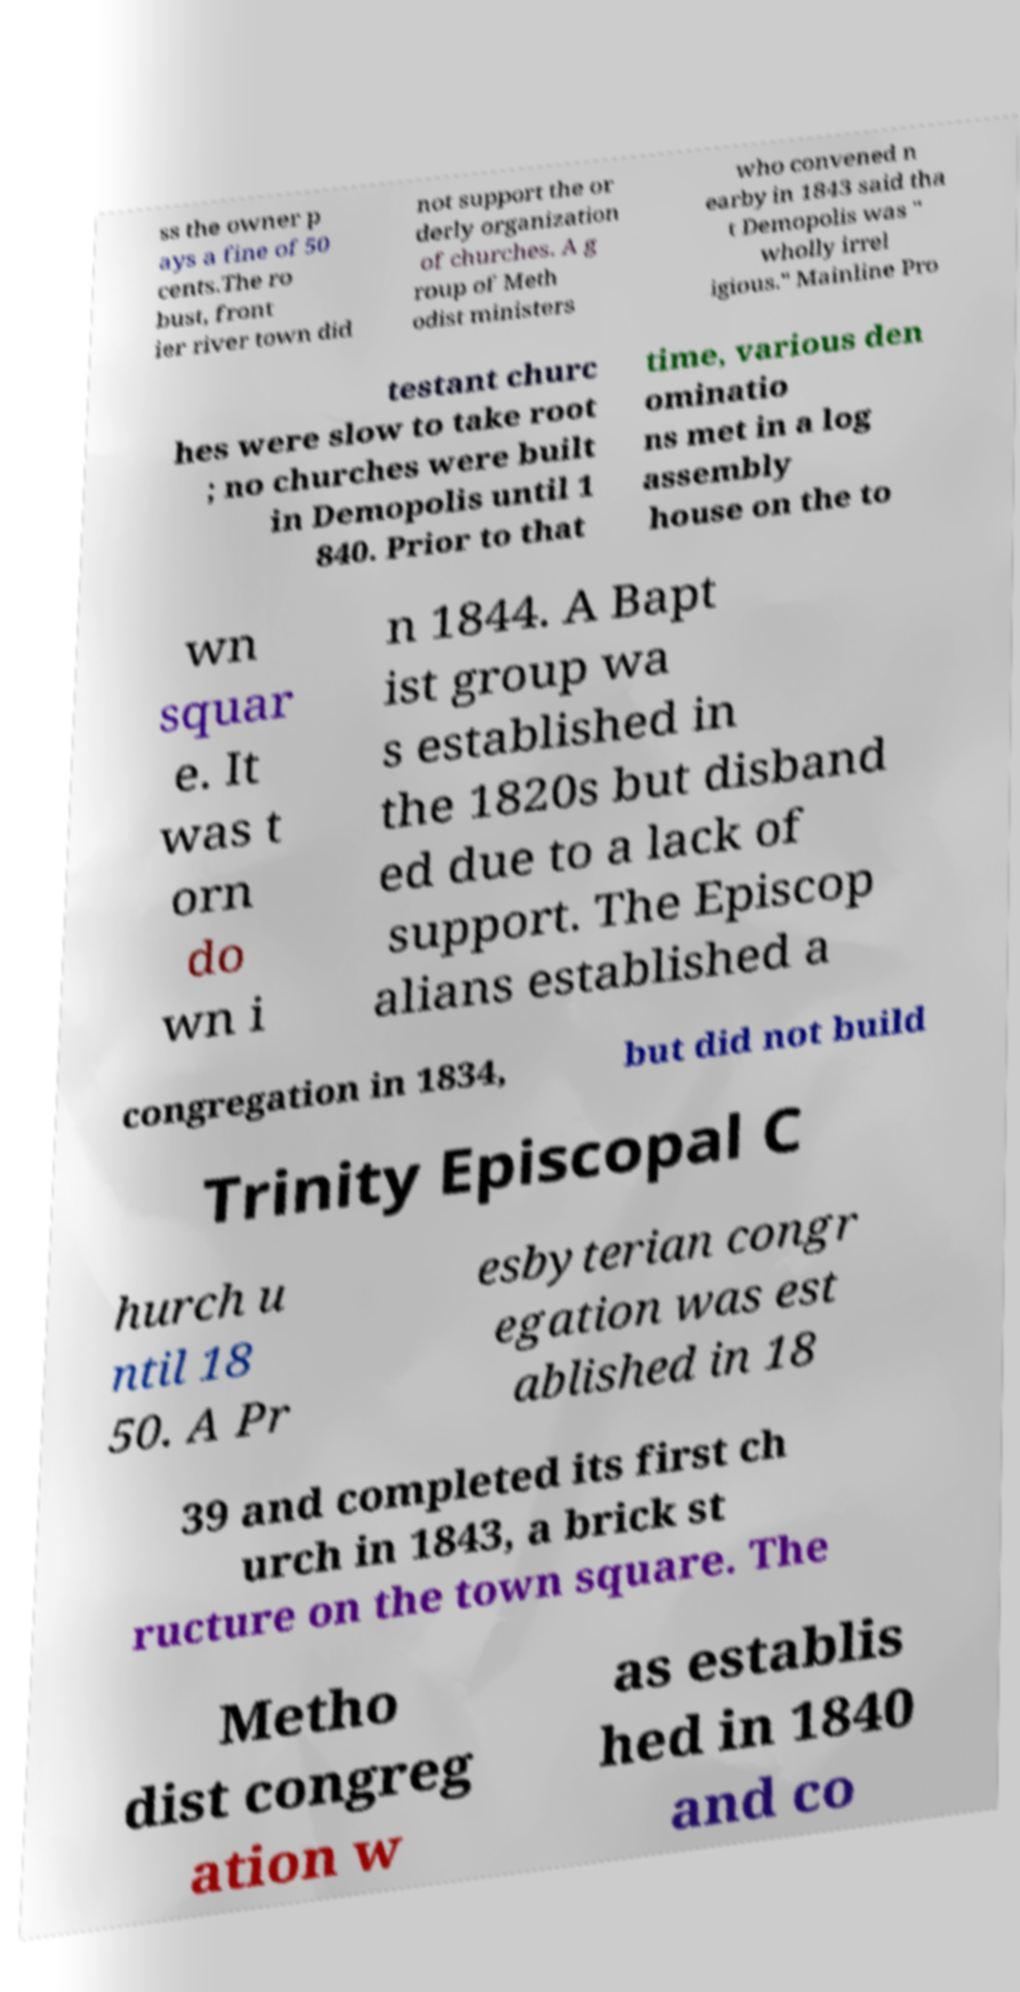Could you assist in decoding the text presented in this image and type it out clearly? ss the owner p ays a fine of 50 cents.The ro bust, front ier river town did not support the or derly organization of churches. A g roup of Meth odist ministers who convened n earby in 1843 said tha t Demopolis was " wholly irrel igious." Mainline Pro testant churc hes were slow to take root ; no churches were built in Demopolis until 1 840. Prior to that time, various den ominatio ns met in a log assembly house on the to wn squar e. It was t orn do wn i n 1844. A Bapt ist group wa s established in the 1820s but disband ed due to a lack of support. The Episcop alians established a congregation in 1834, but did not build Trinity Episcopal C hurch u ntil 18 50. A Pr esbyterian congr egation was est ablished in 18 39 and completed its first ch urch in 1843, a brick st ructure on the town square. The Metho dist congreg ation w as establis hed in 1840 and co 